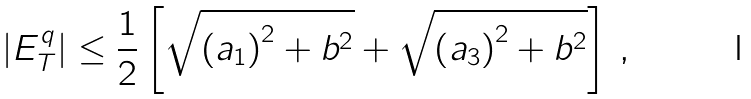<formula> <loc_0><loc_0><loc_500><loc_500>| E _ { T } ^ { q } | \leq \frac { 1 } { 2 } \left [ \sqrt { \left ( a _ { 1 } \right ) ^ { 2 } + b ^ { 2 } } + \sqrt { \left ( a _ { 3 } \right ) ^ { 2 } + b ^ { 2 } } \right ] \, ,</formula> 